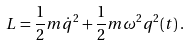Convert formula to latex. <formula><loc_0><loc_0><loc_500><loc_500>L = \frac { 1 } { 2 } m \dot { q } ^ { 2 } + \frac { 1 } { 2 } m \omega ^ { 2 } q ^ { 2 } ( t ) \, .</formula> 